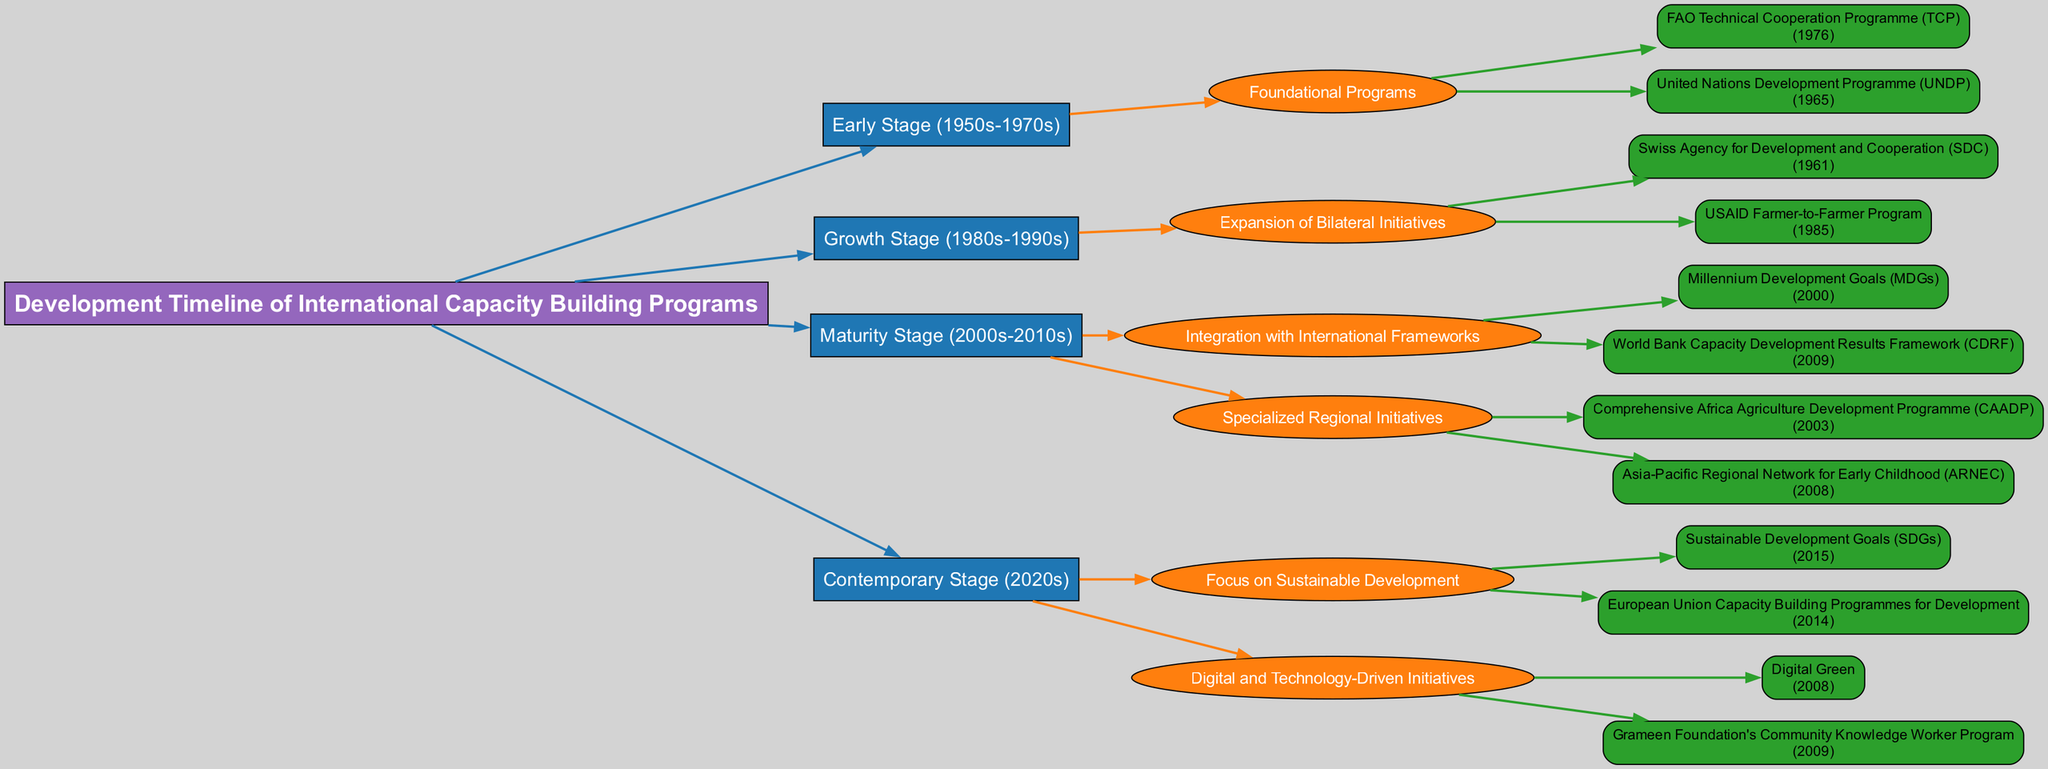What is the earliest program listed in the diagram? The diagram lists several programs under the "Early Stage (1950s-1970s)" category. The earliest program mentioned is the United Nations Development Programme (UNDP), established in 1965.
Answer: United Nations Development Programme (UNDP) How many stages are there in the development timeline? The timeline consists of four distinct stages: Early Stage, Growth Stage, Maturity Stage, and Contemporary Stage. Counting these stages gives a total of four.
Answer: 4 What year did the Sustainable Development Goals (SDGs) start? Within the "Contemporary Stage (2020s)" section of the diagram, the Sustainable Development Goals (SDGs) are notably marked as having started in the year 2015.
Answer: 2015 Which program was established by the Swiss Agency for Development and Cooperation (SDC)? In the "Growth Stage (1980s-1990s)", the document identifies the Swiss Agency for Development and Cooperation (SDC) as being initiated in 1961, and it is one of the bilateral initiatives listed under that stage.
Answer: Swiss Agency for Development and Cooperation (SDC) What is the relationship between the Millennium Development Goals (MDGs) and the World Bank Capacity Development Results Framework (CDRF)? Both the Millennium Development Goals (MDGs) and the World Bank Capacity Development Results Framework (CDRF) reside under the same category "Integration with International Frameworks" within the "Maturity Stage (2000s-2010s)". This indicates that they are part of a similar effort to integrate capacity building into international frameworks.
Answer: They are both part of "Integration with International Frameworks." What is the color scheme used in the diagram for the "Maturity Stage"? The "Maturity Stage (2000s-2010s)" employs a specific color from the defined color scheme in the diagram. This stage is represented using the color green.
Answer: Green How many programs are listed under the "Focus on Sustainable Development"? The "Focus on Sustainable Development" category, under the "Contemporary Stage (2020s)", includes two programs: Sustainable Development Goals (SDGs) and European Union Capacity Building Programmes for Development. Therefore, there are two programs listed in this category.
Answer: 2 Which year is associated with the Comprehensive Africa Agriculture Development Programme (CAADP)? Within the "Specialized Regional Initiatives" under the "Maturity Stage (2000s-2010s)", the Comprehensive Africa Agriculture Development Programme (CAADP) is specifically noted to have been established in the year 2003.
Answer: 2003 